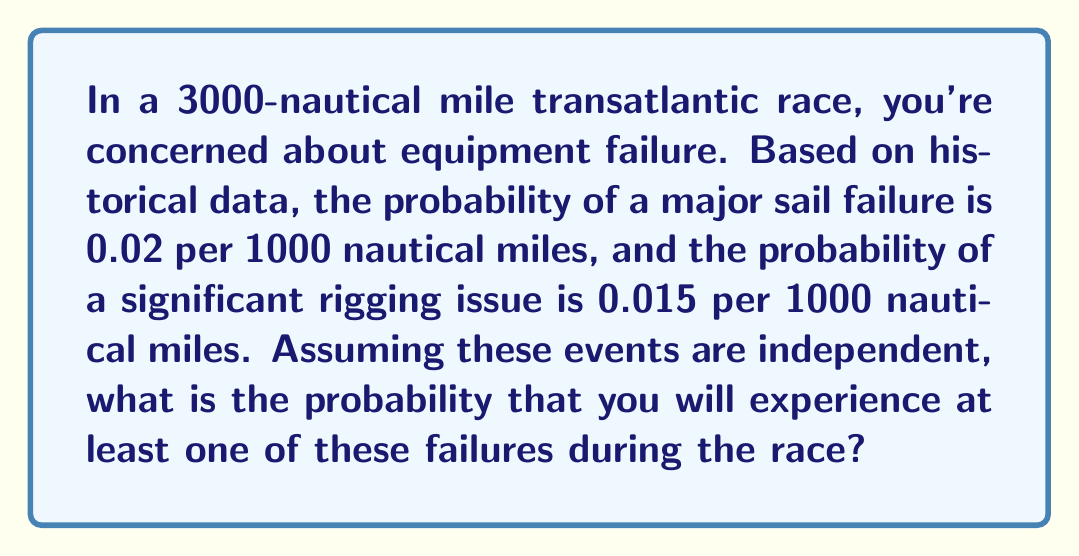Could you help me with this problem? Let's approach this step-by-step:

1) First, we need to calculate the probability of each type of failure for the entire 3000-nautical mile race:

   For sail failure: $P(\text{sail}) = 1 - (1 - 0.02)^3 = 1 - 0.98^3 = 0.0588$
   For rigging issue: $P(\text{rig}) = 1 - (1 - 0.015)^3 = 1 - 0.985^3 = 0.0444$

2) Now, we want to find the probability of at least one of these failures occurring. It's easier to calculate the probability of neither occurring and then subtract from 1:

   $P(\text{at least one}) = 1 - P(\text{neither})$

3) Since the events are independent, we can multiply the probabilities of each event not occurring:

   $P(\text{neither}) = (1 - P(\text{sail})) \times (1 - P(\text{rig}))$
   $= (1 - 0.0588) \times (1 - 0.0444)$
   $= 0.9412 \times 0.9556$
   $= 0.8994$

4) Therefore, the probability of at least one failure is:

   $P(\text{at least one}) = 1 - 0.8994 = 0.1006$
Answer: 0.1006 